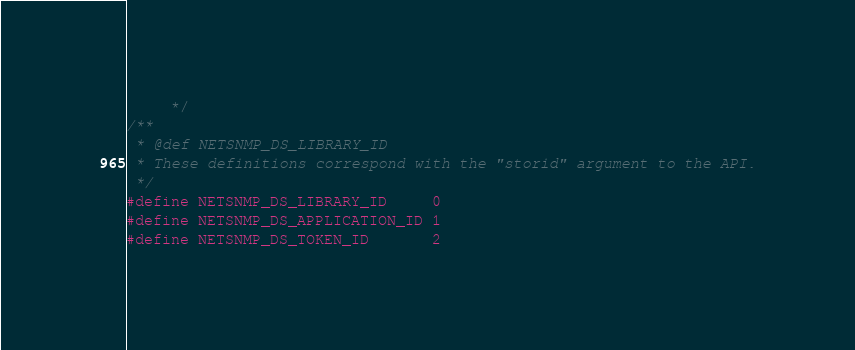Convert code to text. <code><loc_0><loc_0><loc_500><loc_500><_C_>     */
/**
 * @def NETSNMP_DS_LIBRARY_ID
 * These definitions correspond with the "storid" argument to the API.
 */
#define NETSNMP_DS_LIBRARY_ID     0
#define NETSNMP_DS_APPLICATION_ID 1
#define NETSNMP_DS_TOKEN_ID       2
</code> 